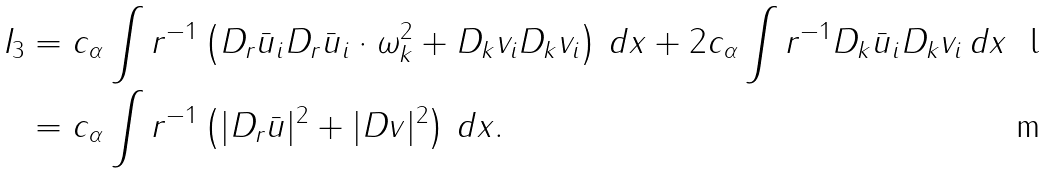Convert formula to latex. <formula><loc_0><loc_0><loc_500><loc_500>I _ { 3 } & = c _ { \alpha } \int r ^ { - 1 } \left ( D _ { r } \bar { u } _ { i } D _ { r } \bar { u } _ { i } \cdot \omega _ { k } ^ { 2 } + D _ { k } v _ { i } D _ { k } v _ { i } \right ) \, d x + 2 c _ { \alpha } \int r ^ { - 1 } D _ { k } \bar { u } _ { i } D _ { k } v _ { i } \, d x \\ & = c _ { \alpha } \int r ^ { - 1 } \left ( | D _ { r } \bar { u } | ^ { 2 } + | D v | ^ { 2 } \right ) \, d x .</formula> 